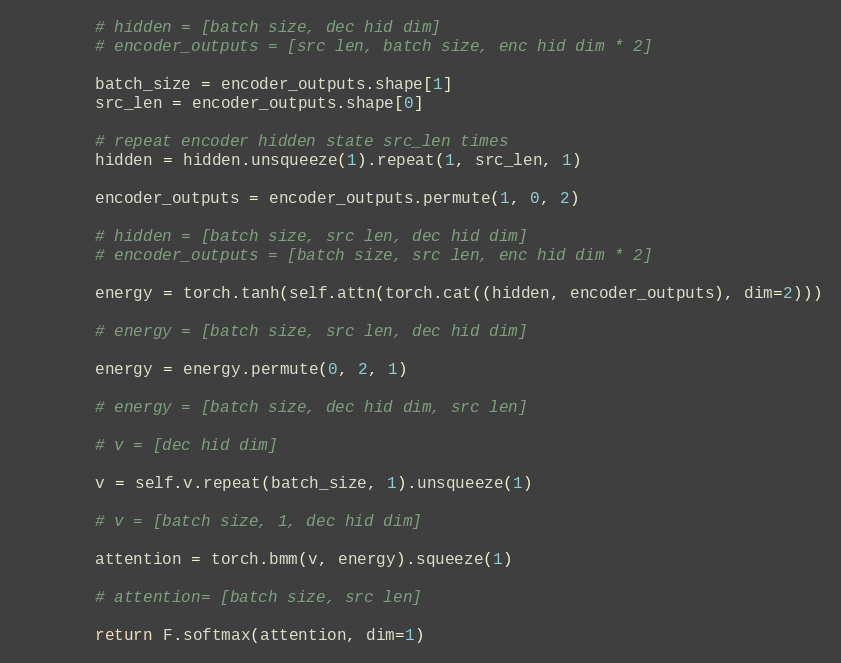<code> <loc_0><loc_0><loc_500><loc_500><_Python_>
        # hidden = [batch size, dec hid dim]
        # encoder_outputs = [src len, batch size, enc hid dim * 2]

        batch_size = encoder_outputs.shape[1]
        src_len = encoder_outputs.shape[0]

        # repeat encoder hidden state src_len times
        hidden = hidden.unsqueeze(1).repeat(1, src_len, 1)

        encoder_outputs = encoder_outputs.permute(1, 0, 2)

        # hidden = [batch size, src len, dec hid dim]
        # encoder_outputs = [batch size, src len, enc hid dim * 2]

        energy = torch.tanh(self.attn(torch.cat((hidden, encoder_outputs), dim=2)))

        # energy = [batch size, src len, dec hid dim]

        energy = energy.permute(0, 2, 1)

        # energy = [batch size, dec hid dim, src len]

        # v = [dec hid dim]

        v = self.v.repeat(batch_size, 1).unsqueeze(1)

        # v = [batch size, 1, dec hid dim]

        attention = torch.bmm(v, energy).squeeze(1)

        # attention= [batch size, src len]

        return F.softmax(attention, dim=1)
</code> 